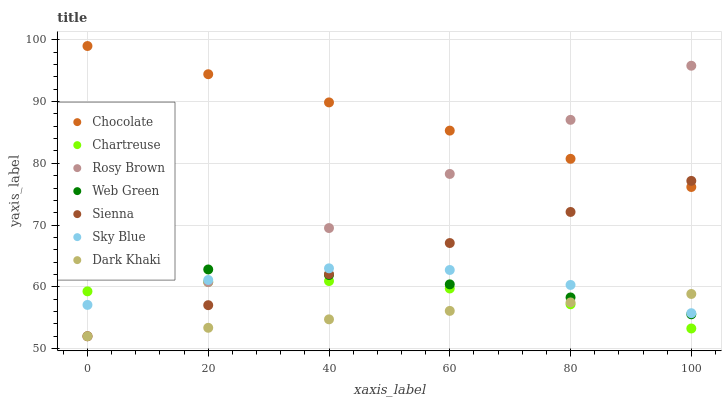Does Dark Khaki have the minimum area under the curve?
Answer yes or no. Yes. Does Chocolate have the maximum area under the curve?
Answer yes or no. Yes. Does Rosy Brown have the minimum area under the curve?
Answer yes or no. No. Does Rosy Brown have the maximum area under the curve?
Answer yes or no. No. Is Sienna the smoothest?
Answer yes or no. Yes. Is Sky Blue the roughest?
Answer yes or no. Yes. Is Rosy Brown the smoothest?
Answer yes or no. No. Is Rosy Brown the roughest?
Answer yes or no. No. Does Dark Khaki have the lowest value?
Answer yes or no. Yes. Does Web Green have the lowest value?
Answer yes or no. No. Does Chocolate have the highest value?
Answer yes or no. Yes. Does Rosy Brown have the highest value?
Answer yes or no. No. Is Sky Blue less than Chocolate?
Answer yes or no. Yes. Is Chocolate greater than Sky Blue?
Answer yes or no. Yes. Does Sky Blue intersect Sienna?
Answer yes or no. Yes. Is Sky Blue less than Sienna?
Answer yes or no. No. Is Sky Blue greater than Sienna?
Answer yes or no. No. Does Sky Blue intersect Chocolate?
Answer yes or no. No. 